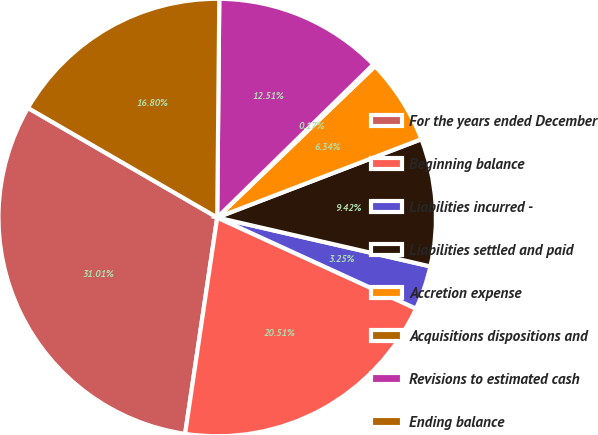<chart> <loc_0><loc_0><loc_500><loc_500><pie_chart><fcel>For the years ended December<fcel>Beginning balance<fcel>Liabilities incurred -<fcel>Liabilities settled and paid<fcel>Accretion expense<fcel>Acquisitions dispositions and<fcel>Revisions to estimated cash<fcel>Ending balance<nl><fcel>31.01%<fcel>20.51%<fcel>3.25%<fcel>9.42%<fcel>6.34%<fcel>0.17%<fcel>12.51%<fcel>16.8%<nl></chart> 